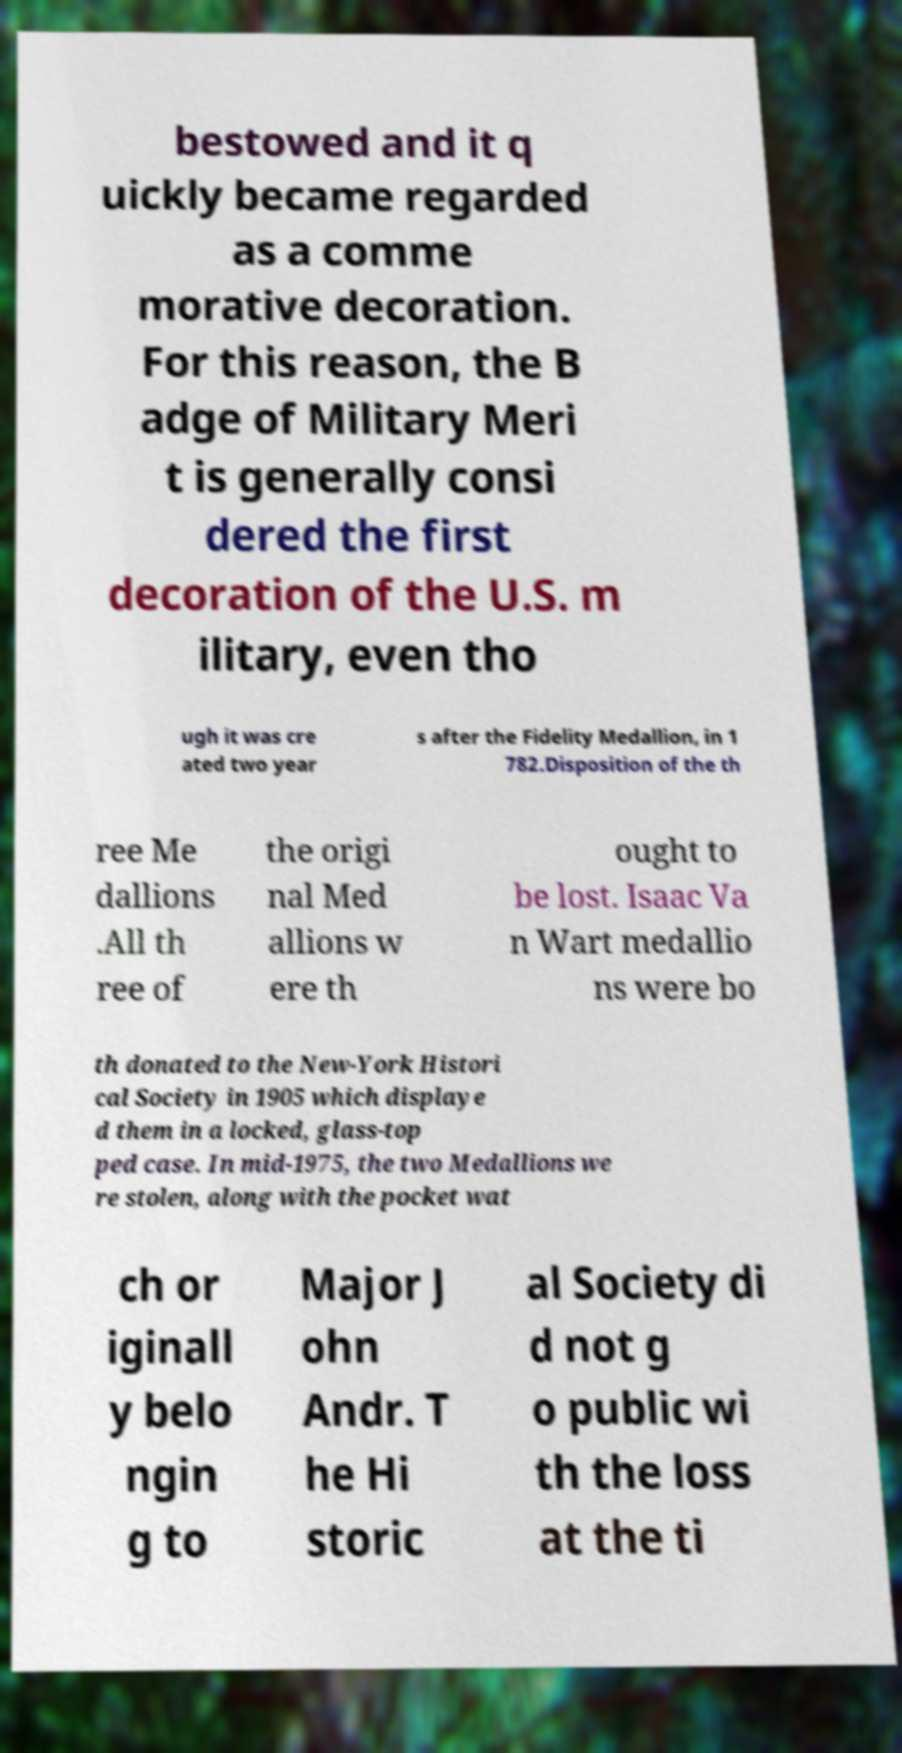Could you extract and type out the text from this image? bestowed and it q uickly became regarded as a comme morative decoration. For this reason, the B adge of Military Meri t is generally consi dered the first decoration of the U.S. m ilitary, even tho ugh it was cre ated two year s after the Fidelity Medallion, in 1 782.Disposition of the th ree Me dallions .All th ree of the origi nal Med allions w ere th ought to be lost. Isaac Va n Wart medallio ns were bo th donated to the New-York Histori cal Society in 1905 which displaye d them in a locked, glass-top ped case. In mid-1975, the two Medallions we re stolen, along with the pocket wat ch or iginall y belo ngin g to Major J ohn Andr. T he Hi storic al Society di d not g o public wi th the loss at the ti 